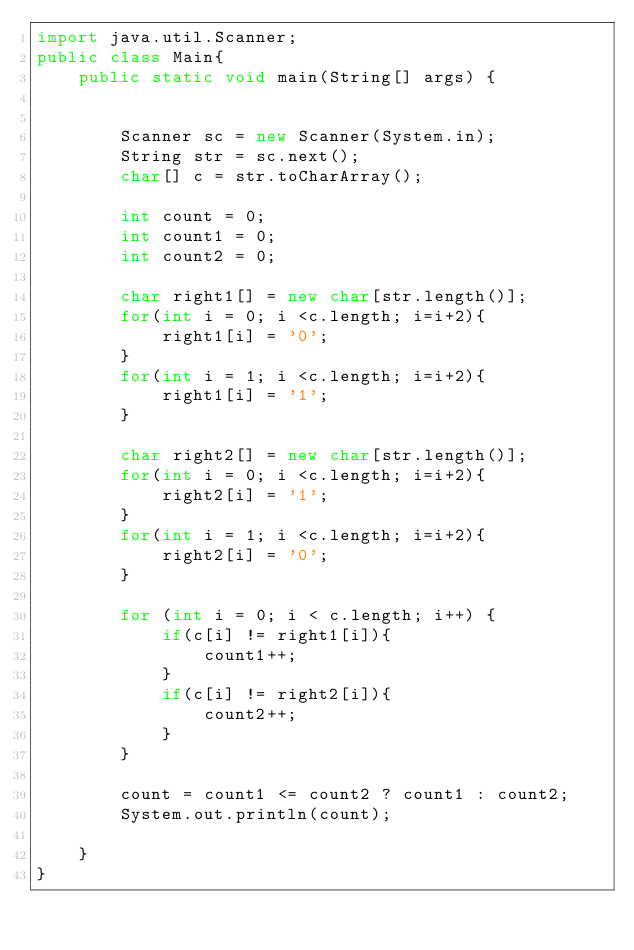Convert code to text. <code><loc_0><loc_0><loc_500><loc_500><_Java_>import java.util.Scanner;
public class Main{
    public static void main(String[] args) {


        Scanner sc = new Scanner(System.in);
        String str = sc.next(); 
        char[] c = str.toCharArray();

        int count = 0;
        int count1 = 0;
        int count2 = 0;

        char right1[] = new char[str.length()];
        for(int i = 0; i <c.length; i=i+2){
            right1[i] = '0';
        }
        for(int i = 1; i <c.length; i=i+2){
            right1[i] = '1';
        }

        char right2[] = new char[str.length()];
        for(int i = 0; i <c.length; i=i+2){
            right2[i] = '1';
        }
        for(int i = 1; i <c.length; i=i+2){
            right2[i] = '0';
        }

        for (int i = 0; i < c.length; i++) {
            if(c[i] != right1[i]){
                count1++;
            }
            if(c[i] != right2[i]){
                count2++;
            }
        }

        count = count1 <= count2 ? count1 : count2;
        System.out.println(count);

    }
}
</code> 